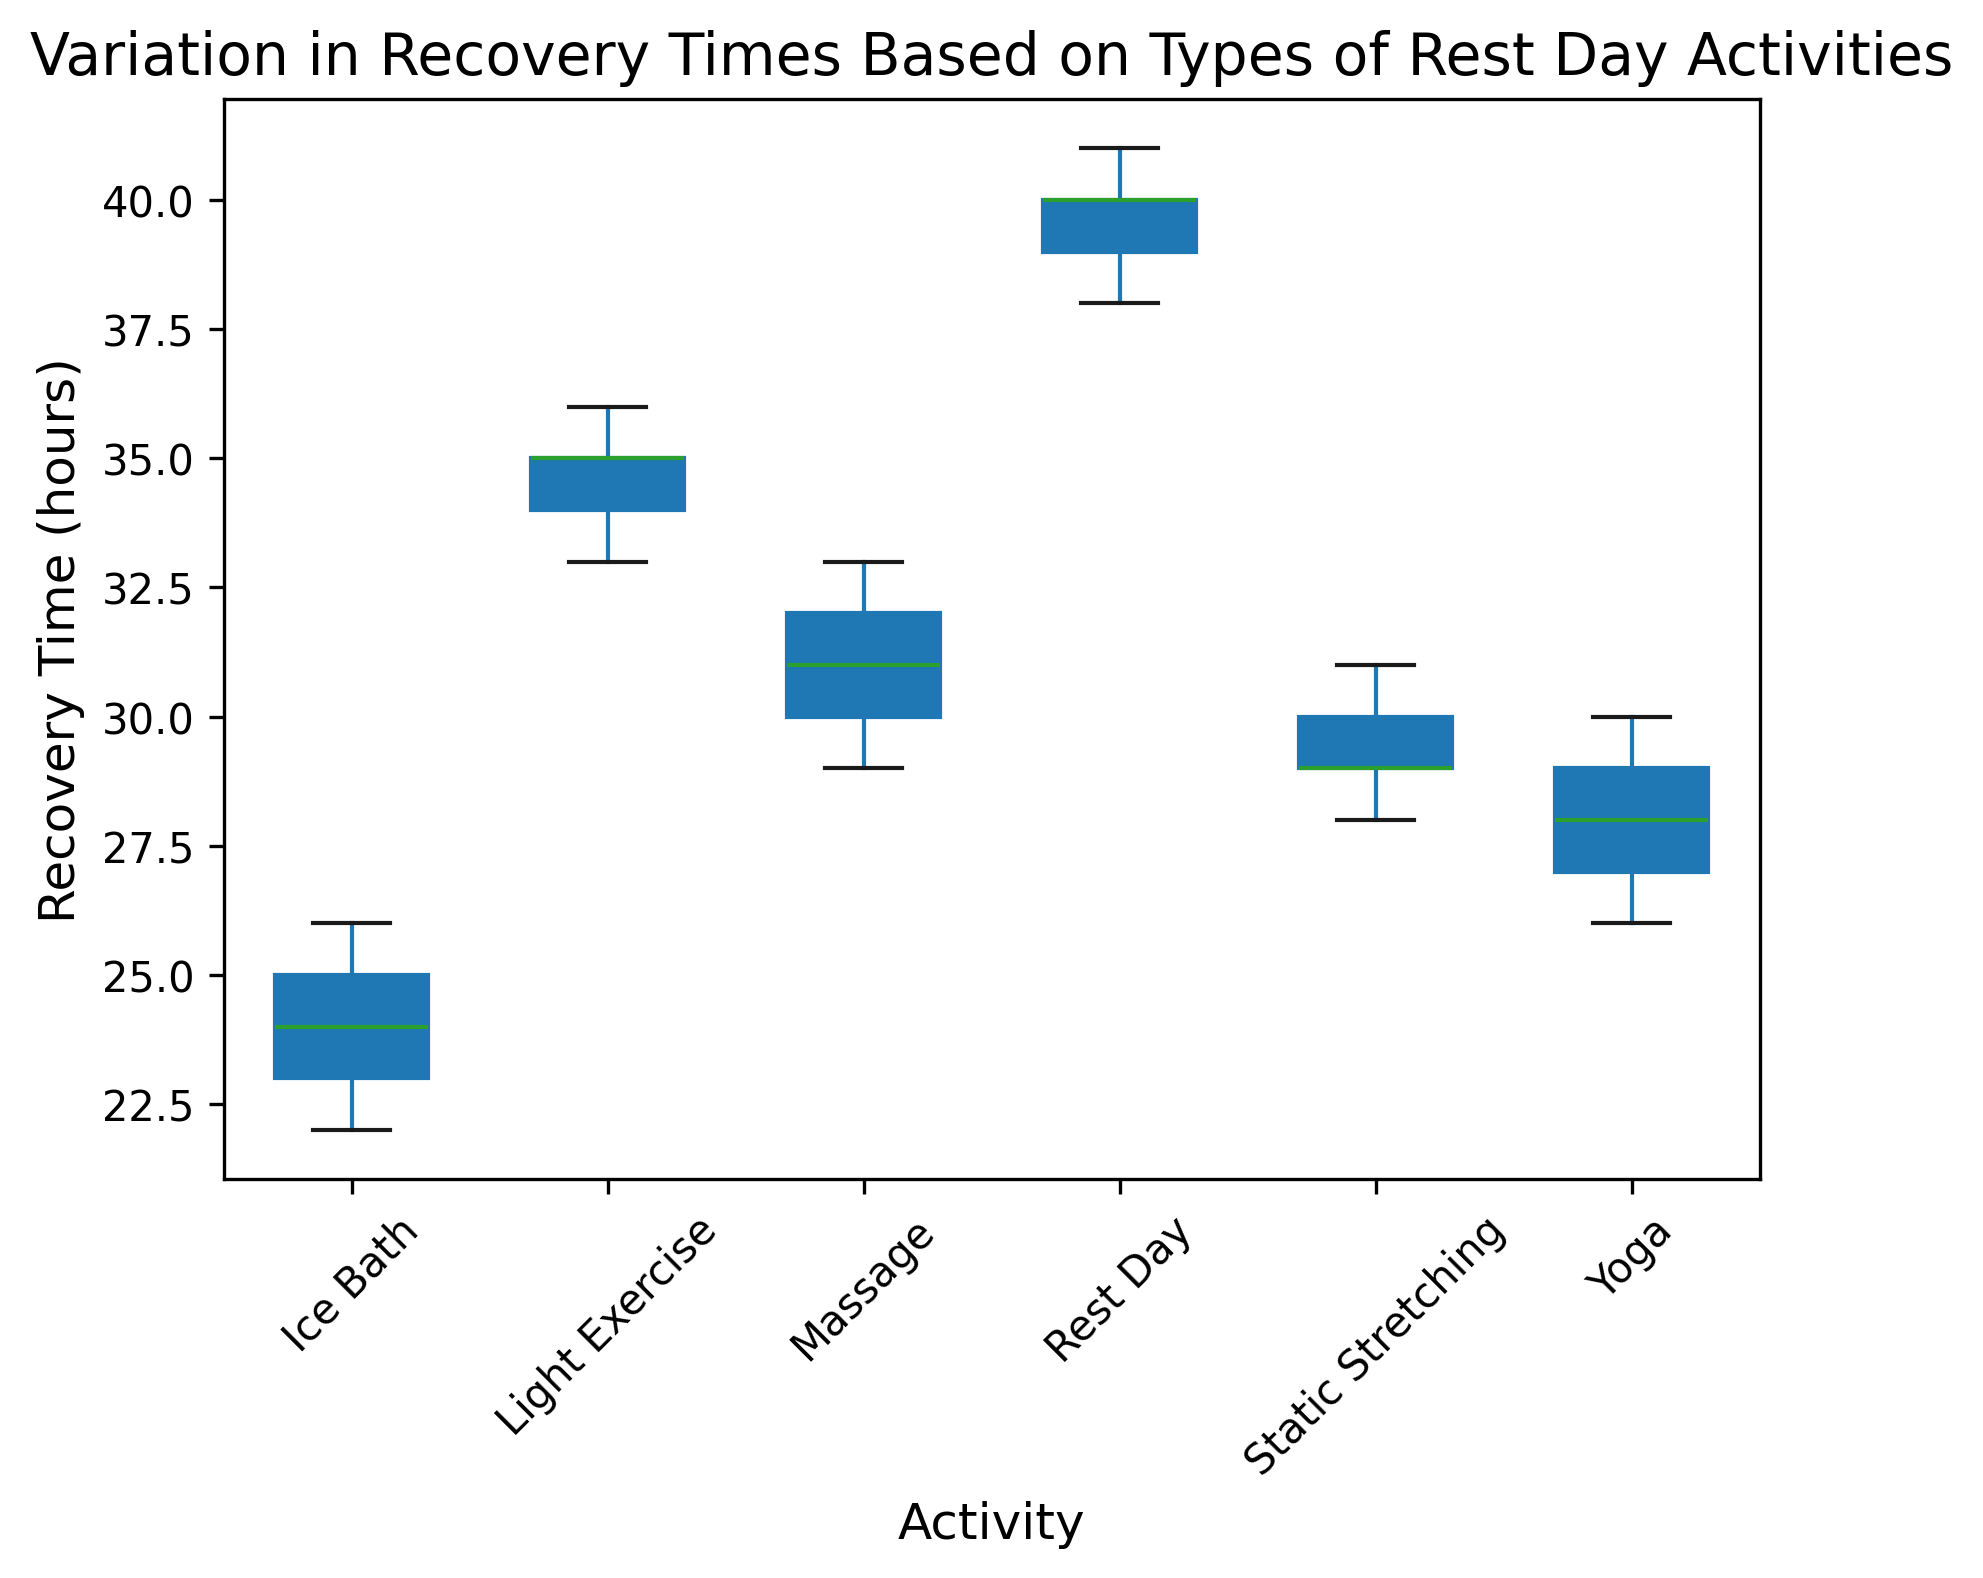What's the median recovery time for the Light Exercise group? To find the median, we first order the recovery times: 33, 34, 35, 35, 36. Since there are 5 data points, the median is the middle value.
Answer: 35 Which activity has the lowest median recovery time? The activities and their medians are: Ice Bath (24.5), Massage (31), Yoga (28), Light Exercise (35), Static Stretching (29), Rest Day (40). The lowest median recovery time is for Ice Bath.
Answer: Ice Bath Do Massage and Static Stretching have similar ranges of recovery times? The range is calculated as the maximum minus the minimum recovery time for each activity. Massage ranges from 29 to 33, and Static Stretching ranges from 28 to 31. Both ranges are of 4 and 3 hours respectively, indicating relatively similar variability.
Answer: Yes What is the interquartile range (IQR) of recovery time for Yoga? The IQR is the difference between the 75th percentile and the 25th percentile. For Yoga, the 25th percentile (Q1) is 27 and the 75th percentile (Q3) is 29. Thus, IQR = Q3 - Q1 = 29 - 27.
Answer: 2 What is the difference between the maximum recovery time in Rest Day and the median recovery time in Ice Bath? The maximum recovery time for Rest Day is 41 and the median for Ice Bath is 24.5. The difference is 41 - 24.5.
Answer: 16.5 Which activity's box plot has the widest spread? Spread can be determined by looking at the range of the box plot. Rest Day has the widest spread, ranging from 38 to 41 hours.
Answer: Rest Day Which activity shows the least variability in recovery times? Variability can be assessed by the height of the boxes in the box plot. Ice Bath has the least variability with the smallest spread from 22 to 26 hours.
Answer: Ice Bath Are there any outliers visible for any of the activities? Outliers are data points that fall outside the whiskers of the box plots. Based on the data provided, there do not appear to be any outliers.
Answer: No What is the difference between the median recovery times for Massage and Static Stretching? The median for Massage is 31, and for Static Stretching, it is 29. The difference is 31 - 29.
Answer: 2 Does Light Exercise or Rest Day have a higher upper quartile value? The upper quartile (75th percentile) is the top edge of the box. For Light Exercise, it is 35. For Rest Day, it is 40. Hence, Rest Day has a higher upper quartile.
Answer: Rest Day 